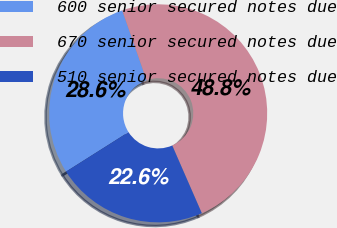Convert chart to OTSL. <chart><loc_0><loc_0><loc_500><loc_500><pie_chart><fcel>600 senior secured notes due<fcel>670 senior secured notes due<fcel>510 senior secured notes due<nl><fcel>28.63%<fcel>48.79%<fcel>22.58%<nl></chart> 